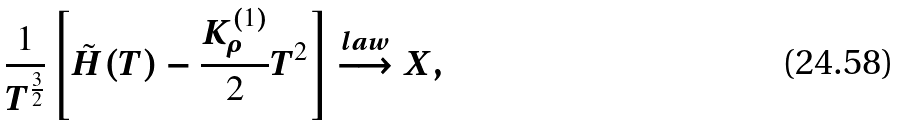<formula> <loc_0><loc_0><loc_500><loc_500>\frac { 1 } { T ^ { \frac { 3 } { 2 } } } \left [ \tilde { H } ( T ) - \frac { K _ { \rho } ^ { \left ( 1 \right ) } } { 2 } T ^ { 2 } \right ] \overset { l a w } { \longrightarrow } X ,</formula> 